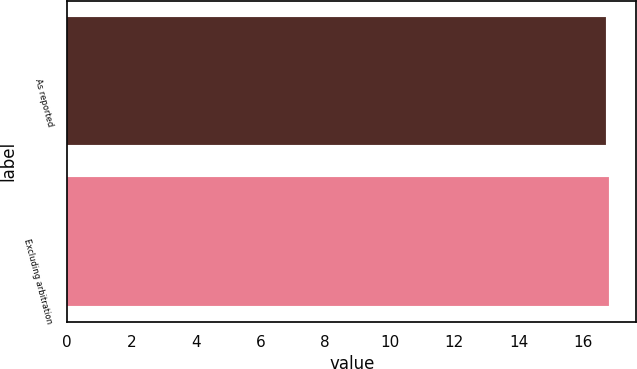Convert chart to OTSL. <chart><loc_0><loc_0><loc_500><loc_500><bar_chart><fcel>As reported<fcel>Excluding arbitration<nl><fcel>16.7<fcel>16.8<nl></chart> 